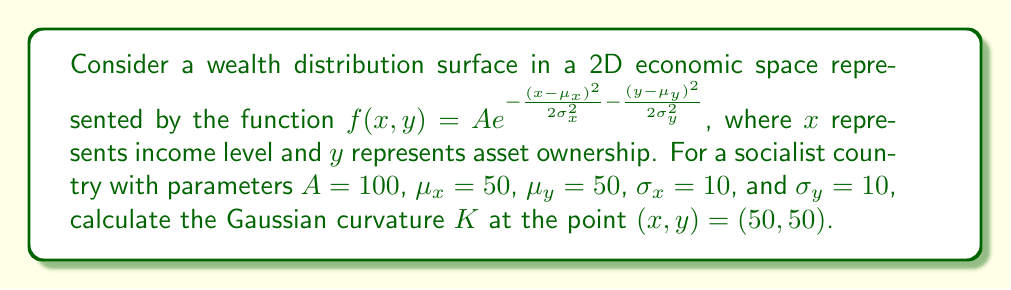Give your solution to this math problem. To calculate the Gaussian curvature $K$, we need to follow these steps:

1) The Gaussian curvature is given by:
   $$K = \frac{f_{xx}f_{yy} - (f_{xy})^2}{(1 + f_x^2 + f_y^2)^2}$$

2) First, let's calculate the partial derivatives:

   $f_x = f(x,y) \cdot (-\frac{x-\mu_x}{\sigma_x^2})$
   
   $f_y = f(x,y) \cdot (-\frac{y-\mu_y}{\sigma_y^2})$
   
   $f_{xx} = f(x,y) \cdot [(\frac{x-\mu_x}{\sigma_x^2})^2 - \frac{1}{\sigma_x^2}]$
   
   $f_{yy} = f(x,y) \cdot [(\frac{y-\mu_y}{\sigma_y^2})^2 - \frac{1}{\sigma_y^2}]$
   
   $f_{xy} = f(x,y) \cdot (\frac{x-\mu_x}{\sigma_x^2}) \cdot (\frac{y-\mu_y}{\sigma_y^2})$

3) At the point $(50,50)$, $x-\mu_x = y-\mu_y = 0$, so:

   $f(50,50) = A = 100$
   
   $f_x = f_y = 0$
   
   $f_{xx} = f_{yy} = -\frac{f(50,50)}{\sigma_x^2} = -\frac{100}{100} = -1$
   
   $f_{xy} = 0$

4) Substituting these values into the Gaussian curvature formula:

   $$K = \frac{(-1)(-1) - (0)^2}{(1 + 0^2 + 0^2)^2} = 1$$

Therefore, the Gaussian curvature $K$ at the point $(50,50)$ is 1.
Answer: $K = 1$ 